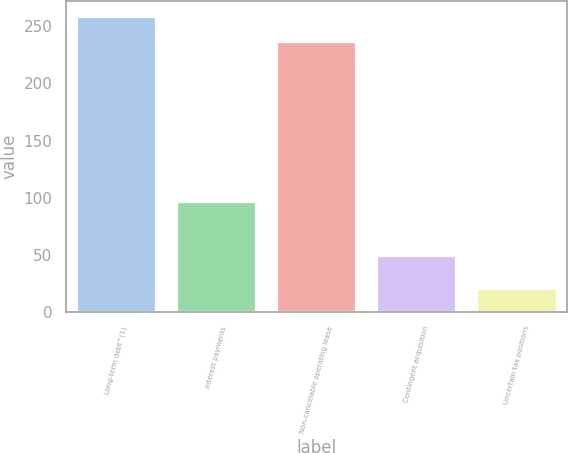Convert chart. <chart><loc_0><loc_0><loc_500><loc_500><bar_chart><fcel>Long-term debt^(1)<fcel>Interest payments<fcel>Non-cancelable operating lease<fcel>Contingent acquisition<fcel>Uncertain tax positions<nl><fcel>259<fcel>96.8<fcel>236.7<fcel>49.8<fcel>21.1<nl></chart> 